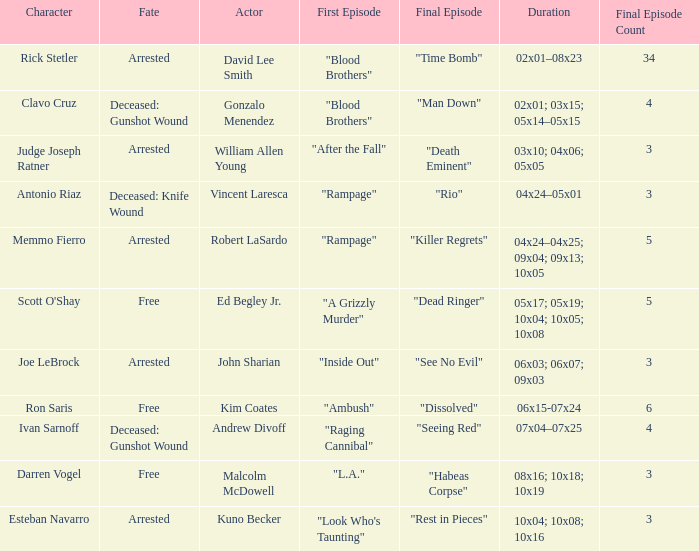What's the character with fate being deceased: knife wound Antonio Riaz. 